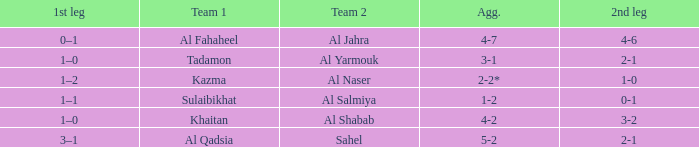What is the 1st leg of the Al Fahaheel Team 1? 0–1. Write the full table. {'header': ['1st leg', 'Team 1', 'Team 2', 'Agg.', '2nd leg'], 'rows': [['0–1', 'Al Fahaheel', 'Al Jahra', '4-7', '4-6'], ['1–0', 'Tadamon', 'Al Yarmouk', '3-1', '2-1'], ['1–2', 'Kazma', 'Al Naser', '2-2*', '1-0'], ['1–1', 'Sulaibikhat', 'Al Salmiya', '1-2', '0-1'], ['1–0', 'Khaitan', 'Al Shabab', '4-2', '3-2'], ['3–1', 'Al Qadsia', 'Sahel', '5-2', '2-1']]} 